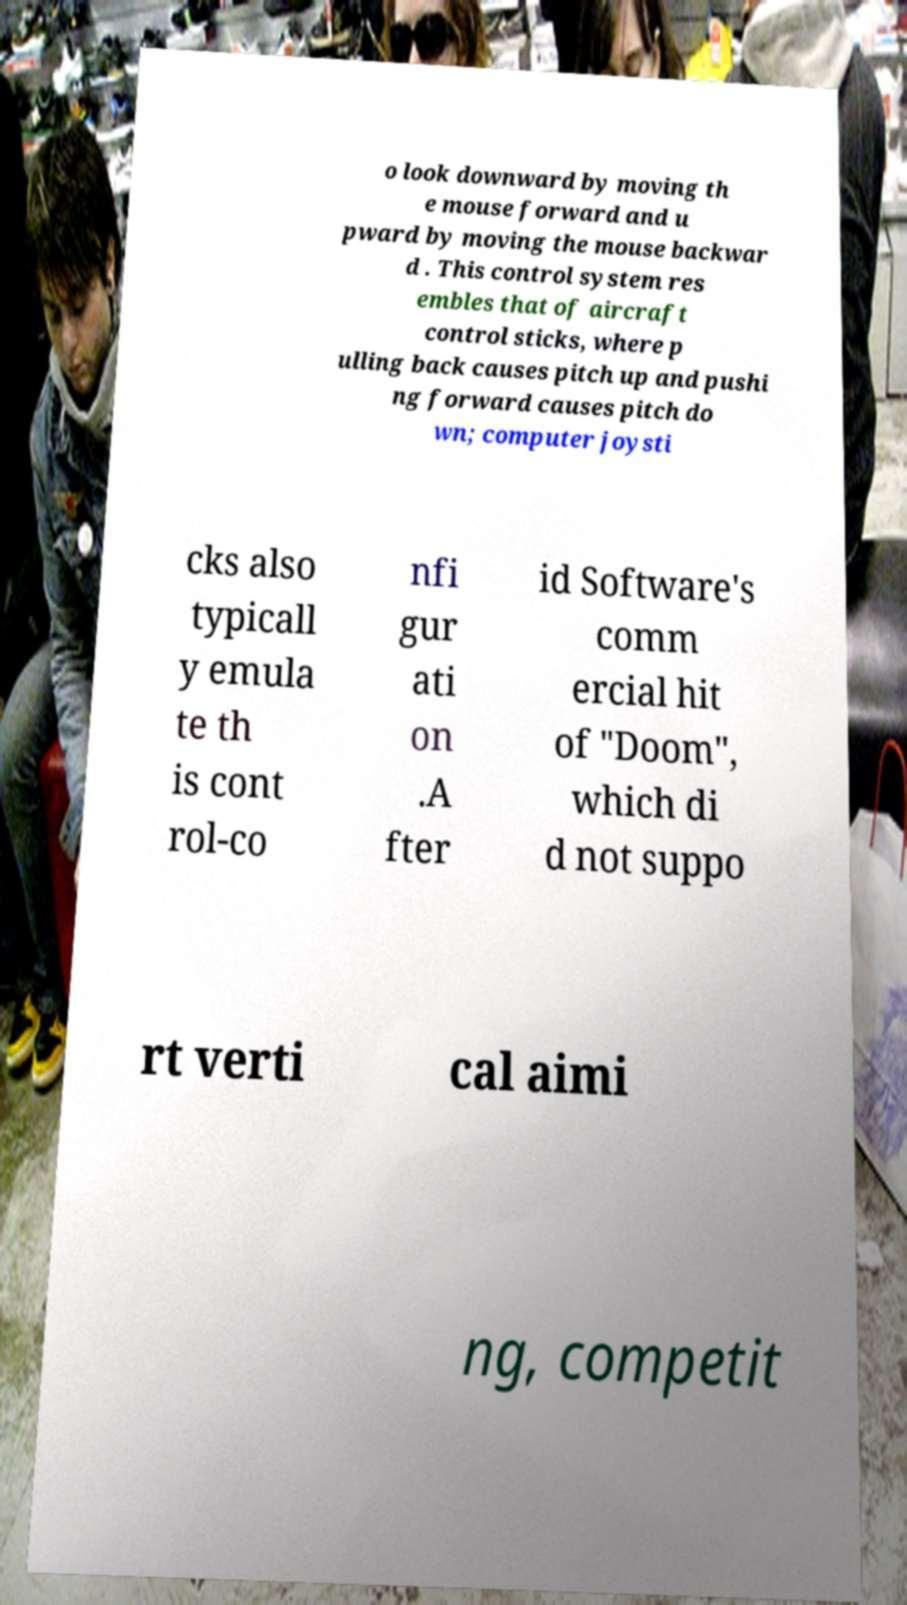I need the written content from this picture converted into text. Can you do that? o look downward by moving th e mouse forward and u pward by moving the mouse backwar d . This control system res embles that of aircraft control sticks, where p ulling back causes pitch up and pushi ng forward causes pitch do wn; computer joysti cks also typicall y emula te th is cont rol-co nfi gur ati on .A fter id Software's comm ercial hit of "Doom", which di d not suppo rt verti cal aimi ng, competit 